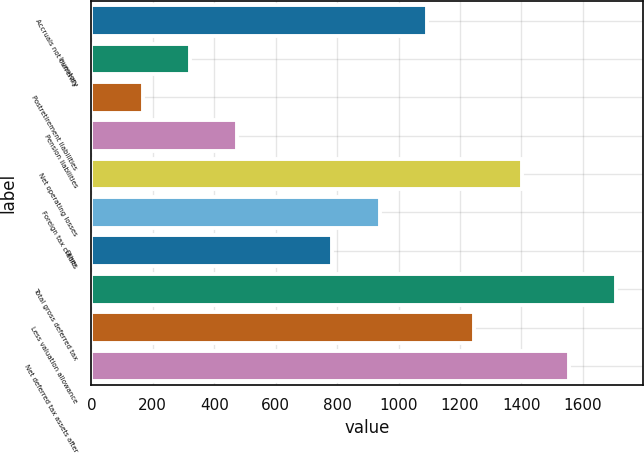Convert chart to OTSL. <chart><loc_0><loc_0><loc_500><loc_500><bar_chart><fcel>Accruals not currently<fcel>Inventory<fcel>Postretirement liabilities<fcel>Pension liabilities<fcel>Net operating losses<fcel>Foreign tax credits<fcel>Other<fcel>Total gross deferred tax<fcel>Less valuation allowance<fcel>Net deferred tax assets after<nl><fcel>1092.22<fcel>321.42<fcel>167.26<fcel>475.58<fcel>1400.54<fcel>938.06<fcel>783.9<fcel>1708.86<fcel>1246.38<fcel>1554.7<nl></chart> 